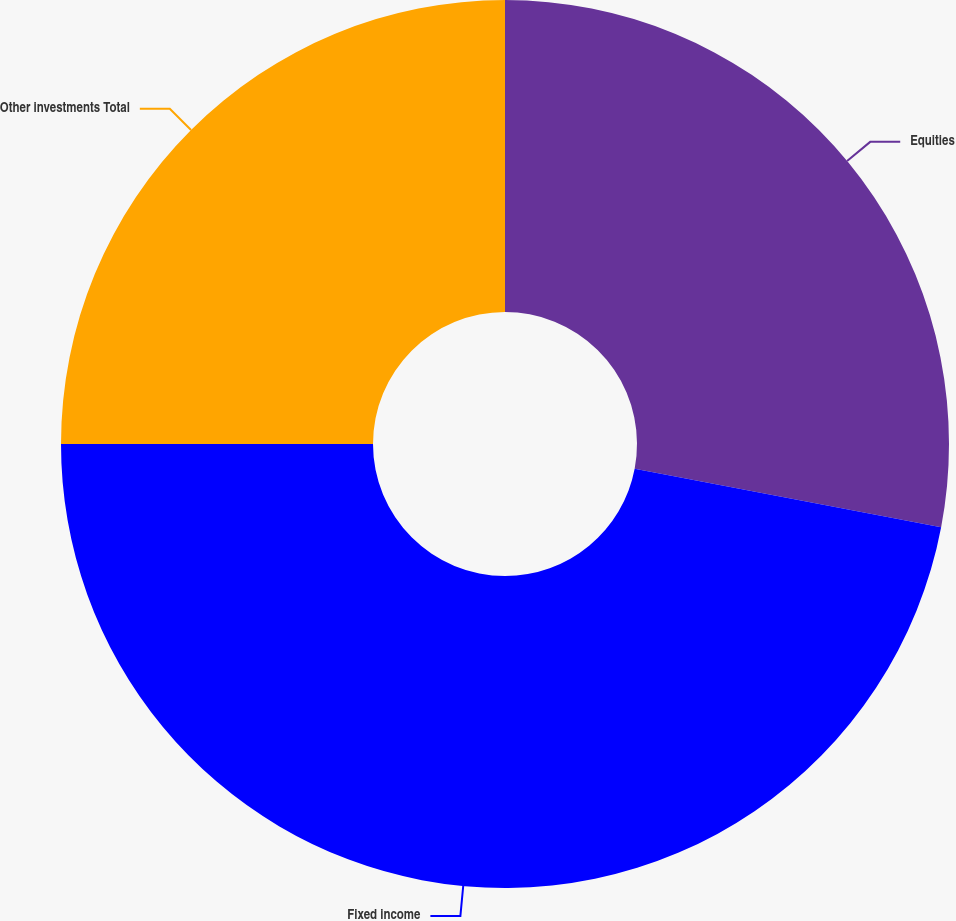Convert chart to OTSL. <chart><loc_0><loc_0><loc_500><loc_500><pie_chart><fcel>Equities<fcel>Fixed income<fcel>Other investments Total<nl><fcel>28.0%<fcel>47.0%<fcel>25.0%<nl></chart> 